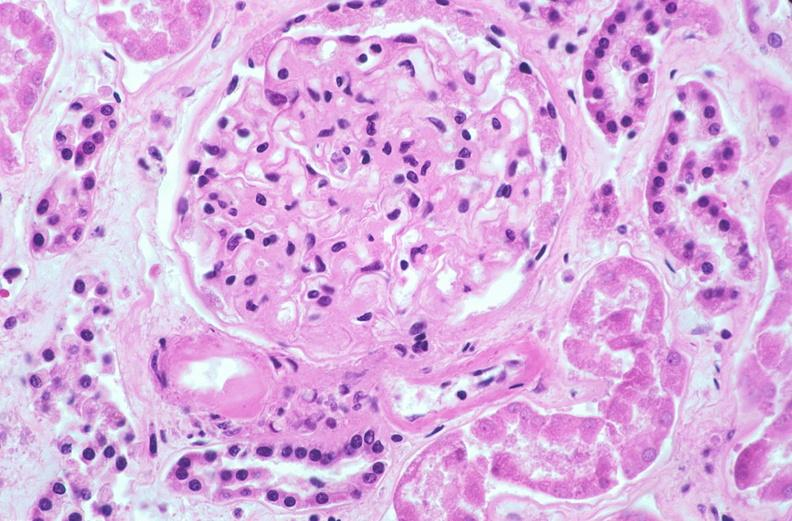why does this image show kidney glomerulus, thickened and hyalinized basement membranes fibrin caps?
Answer the question using a single word or phrase. Due to diabetes mellitus 